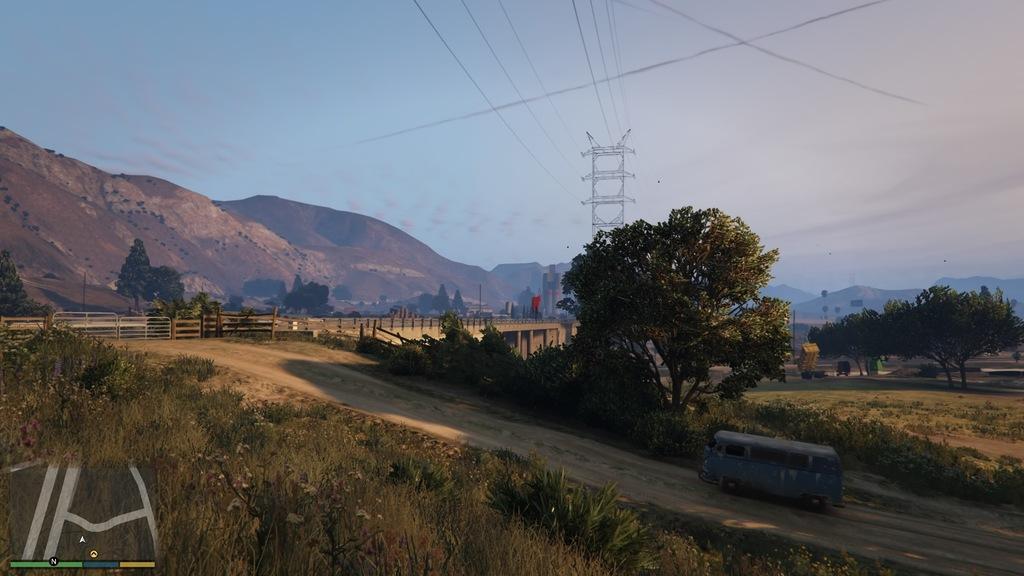In one or two sentences, can you explain what this image depicts? In the center of the image there is a bridge. There are trees. There is a car. In the background of the image there are mountains. At the bottom of the image there is grass. There is a electric tower. 